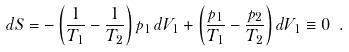<formula> <loc_0><loc_0><loc_500><loc_500>d S = - \left ( \frac { 1 } { T _ { 1 } } - \frac { 1 } { T _ { 2 } } \right ) p _ { 1 } \, d V _ { 1 } + \left ( \frac { p _ { 1 } } { T _ { 1 } } - \frac { p _ { 2 } } { T _ { 2 } } \right ) d V _ { 1 } \equiv 0 \ .</formula> 